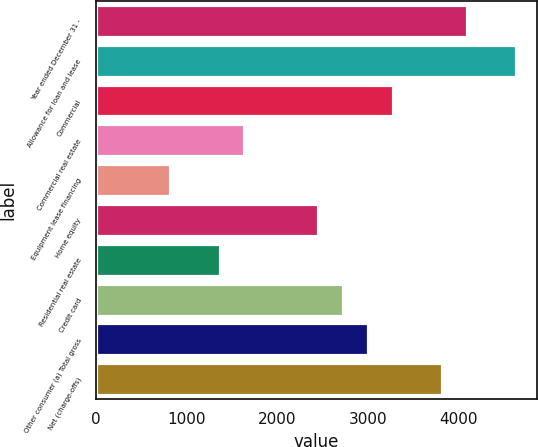Convert chart. <chart><loc_0><loc_0><loc_500><loc_500><bar_chart><fcel>Year ended December 31 -<fcel>Allowance for loan and lease<fcel>Commercial<fcel>Commercial real estate<fcel>Equipment lease financing<fcel>Home equity<fcel>Residential real estate<fcel>Credit card<fcel>Other consumer (a) Total gross<fcel>Net (charge-offs)<nl><fcel>4090.31<fcel>4635.65<fcel>3272.3<fcel>1636.28<fcel>818.27<fcel>2454.29<fcel>1363.61<fcel>2726.96<fcel>2999.63<fcel>3817.64<nl></chart> 